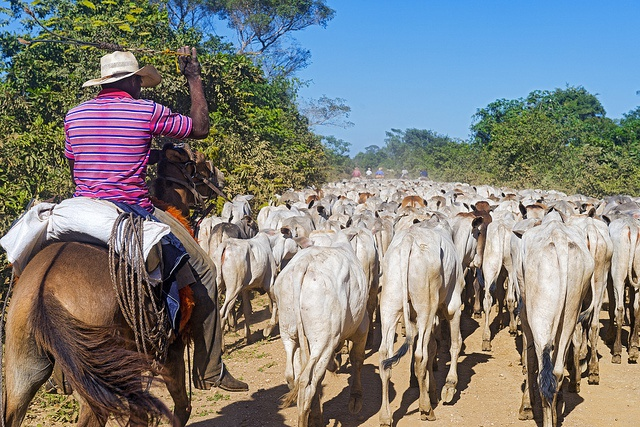Describe the objects in this image and their specific colors. I can see horse in lightblue, black, maroon, gray, and brown tones, people in lightblue, black, violet, gray, and magenta tones, cow in lightblue, lightgray, tan, and darkgray tones, cow in lightblue, lightgray, and darkgray tones, and cow in lightblue, lightgray, tan, and darkgray tones in this image. 